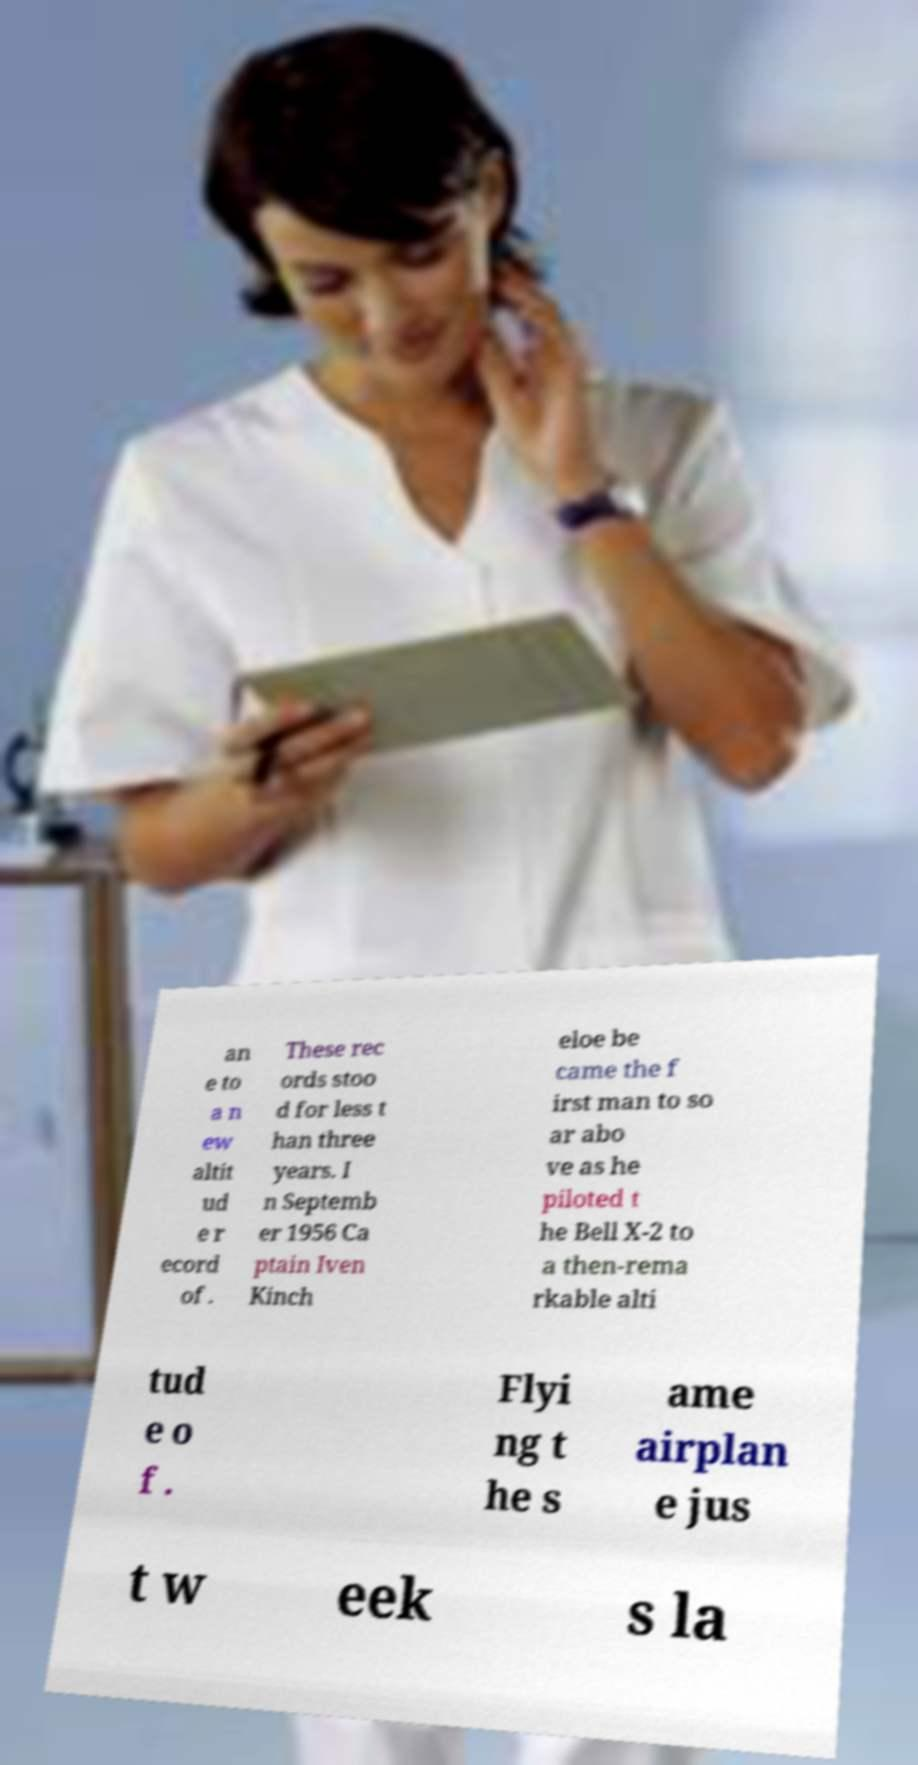Please identify and transcribe the text found in this image. an e to a n ew altit ud e r ecord of . These rec ords stoo d for less t han three years. I n Septemb er 1956 Ca ptain Iven Kinch eloe be came the f irst man to so ar abo ve as he piloted t he Bell X-2 to a then-rema rkable alti tud e o f . Flyi ng t he s ame airplan e jus t w eek s la 